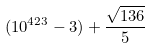Convert formula to latex. <formula><loc_0><loc_0><loc_500><loc_500>( 1 0 ^ { 4 2 3 } - 3 ) + \frac { \sqrt { 1 3 6 } } { 5 }</formula> 